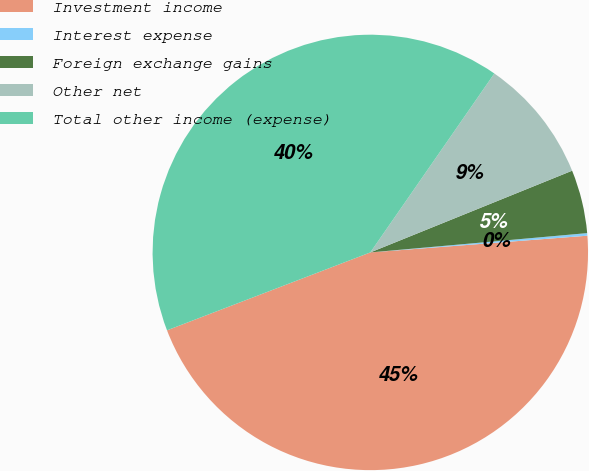Convert chart to OTSL. <chart><loc_0><loc_0><loc_500><loc_500><pie_chart><fcel>Investment income<fcel>Interest expense<fcel>Foreign exchange gains<fcel>Other net<fcel>Total other income (expense)<nl><fcel>45.4%<fcel>0.19%<fcel>4.71%<fcel>9.23%<fcel>40.47%<nl></chart> 